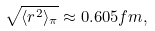Convert formula to latex. <formula><loc_0><loc_0><loc_500><loc_500>\sqrt { \langle r ^ { 2 } \rangle _ { \pi } } \approx 0 . 6 0 5 f m ,</formula> 